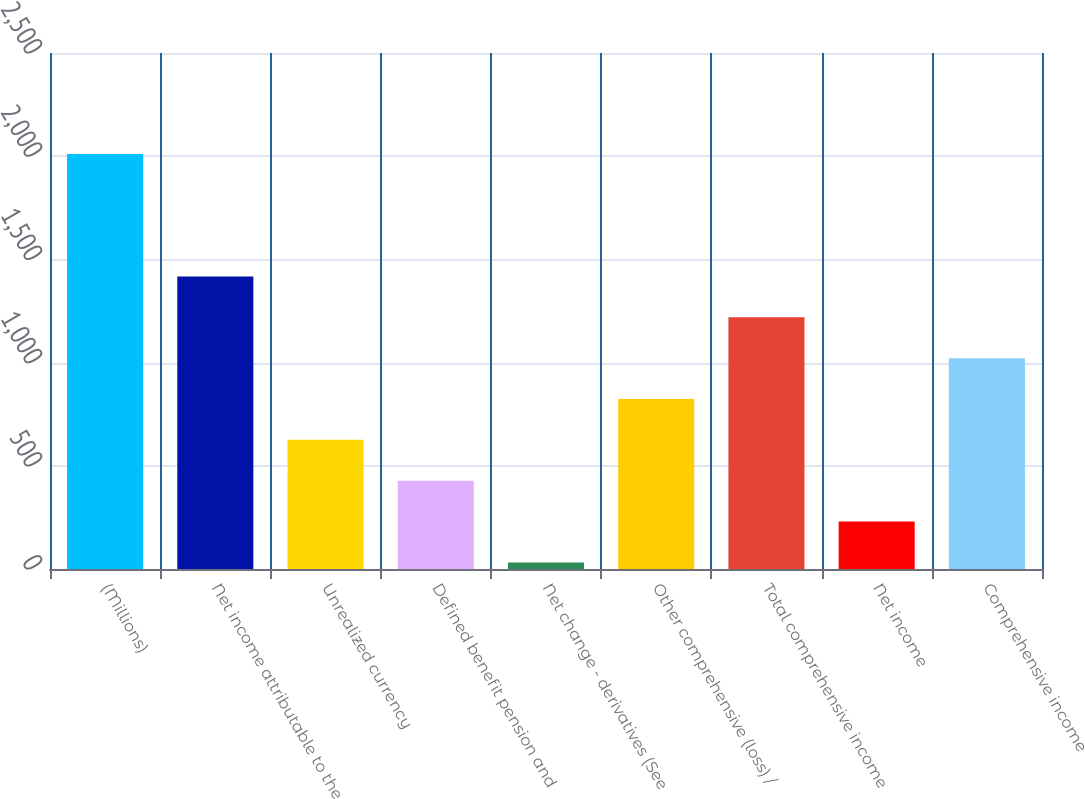Convert chart. <chart><loc_0><loc_0><loc_500><loc_500><bar_chart><fcel>(Millions)<fcel>Net income attributable to the<fcel>Unrealized currency<fcel>Defined benefit pension and<fcel>Net change - derivatives (See<fcel>Other comprehensive (loss) /<fcel>Total comprehensive income<fcel>Net income<fcel>Comprehensive income<nl><fcel>2011<fcel>1417.3<fcel>625.7<fcel>427.8<fcel>32<fcel>823.6<fcel>1219.4<fcel>229.9<fcel>1021.5<nl></chart> 